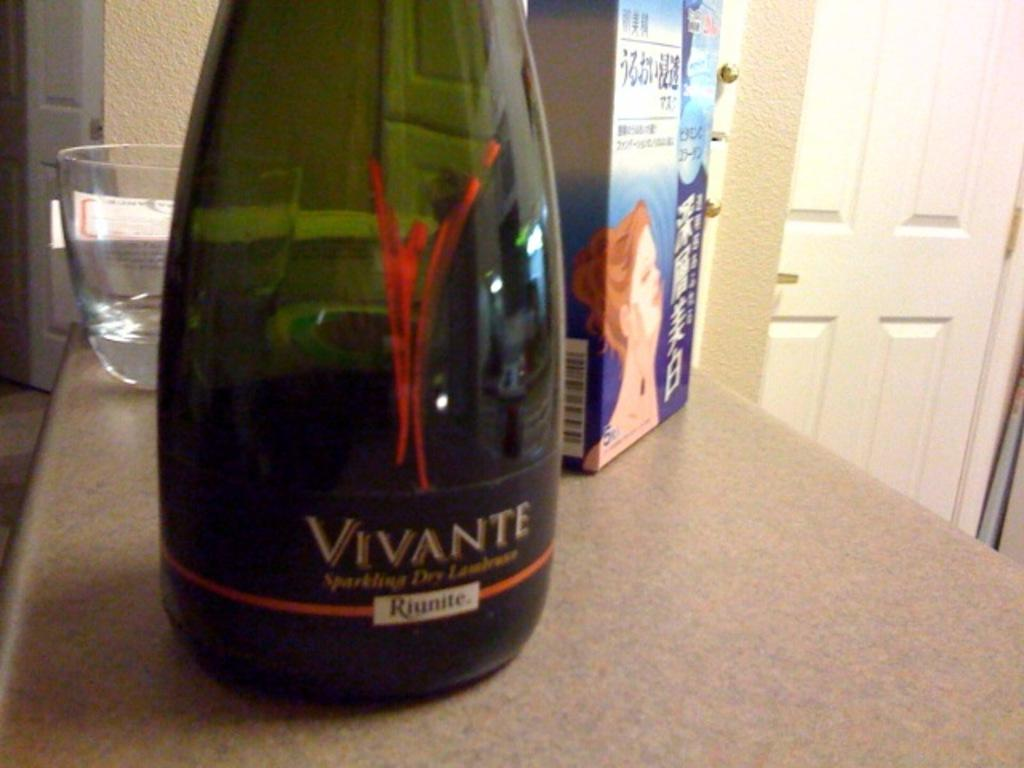<image>
Create a compact narrative representing the image presented. a bottle of Riunite vivante is istting on a table 